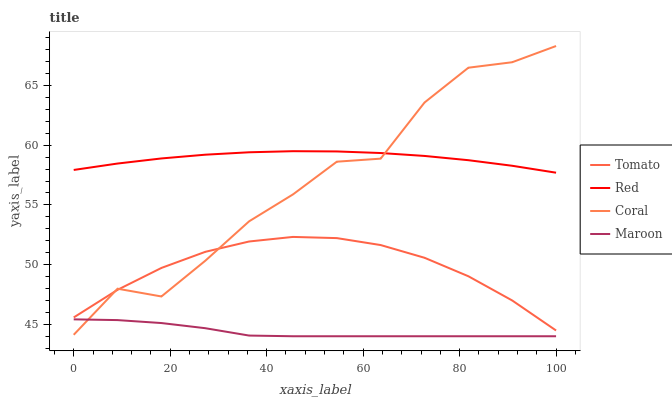Does Maroon have the minimum area under the curve?
Answer yes or no. Yes. Does Red have the maximum area under the curve?
Answer yes or no. Yes. Does Coral have the minimum area under the curve?
Answer yes or no. No. Does Coral have the maximum area under the curve?
Answer yes or no. No. Is Red the smoothest?
Answer yes or no. Yes. Is Coral the roughest?
Answer yes or no. Yes. Is Maroon the smoothest?
Answer yes or no. No. Is Maroon the roughest?
Answer yes or no. No. Does Maroon have the lowest value?
Answer yes or no. Yes. Does Coral have the lowest value?
Answer yes or no. No. Does Coral have the highest value?
Answer yes or no. Yes. Does Maroon have the highest value?
Answer yes or no. No. Is Maroon less than Tomato?
Answer yes or no. Yes. Is Tomato greater than Maroon?
Answer yes or no. Yes. Does Red intersect Coral?
Answer yes or no. Yes. Is Red less than Coral?
Answer yes or no. No. Is Red greater than Coral?
Answer yes or no. No. Does Maroon intersect Tomato?
Answer yes or no. No. 